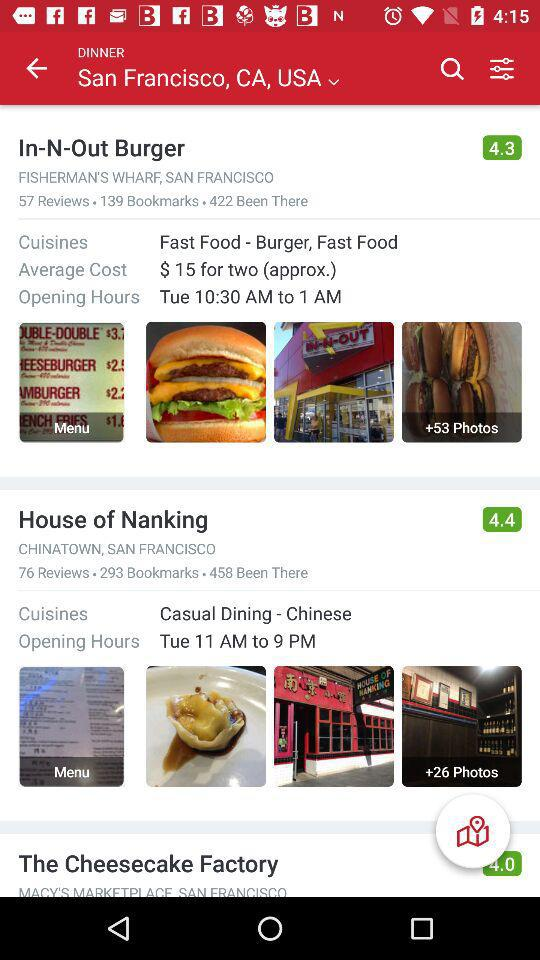What is the average cost? The average cost is approximately $15 for two. 